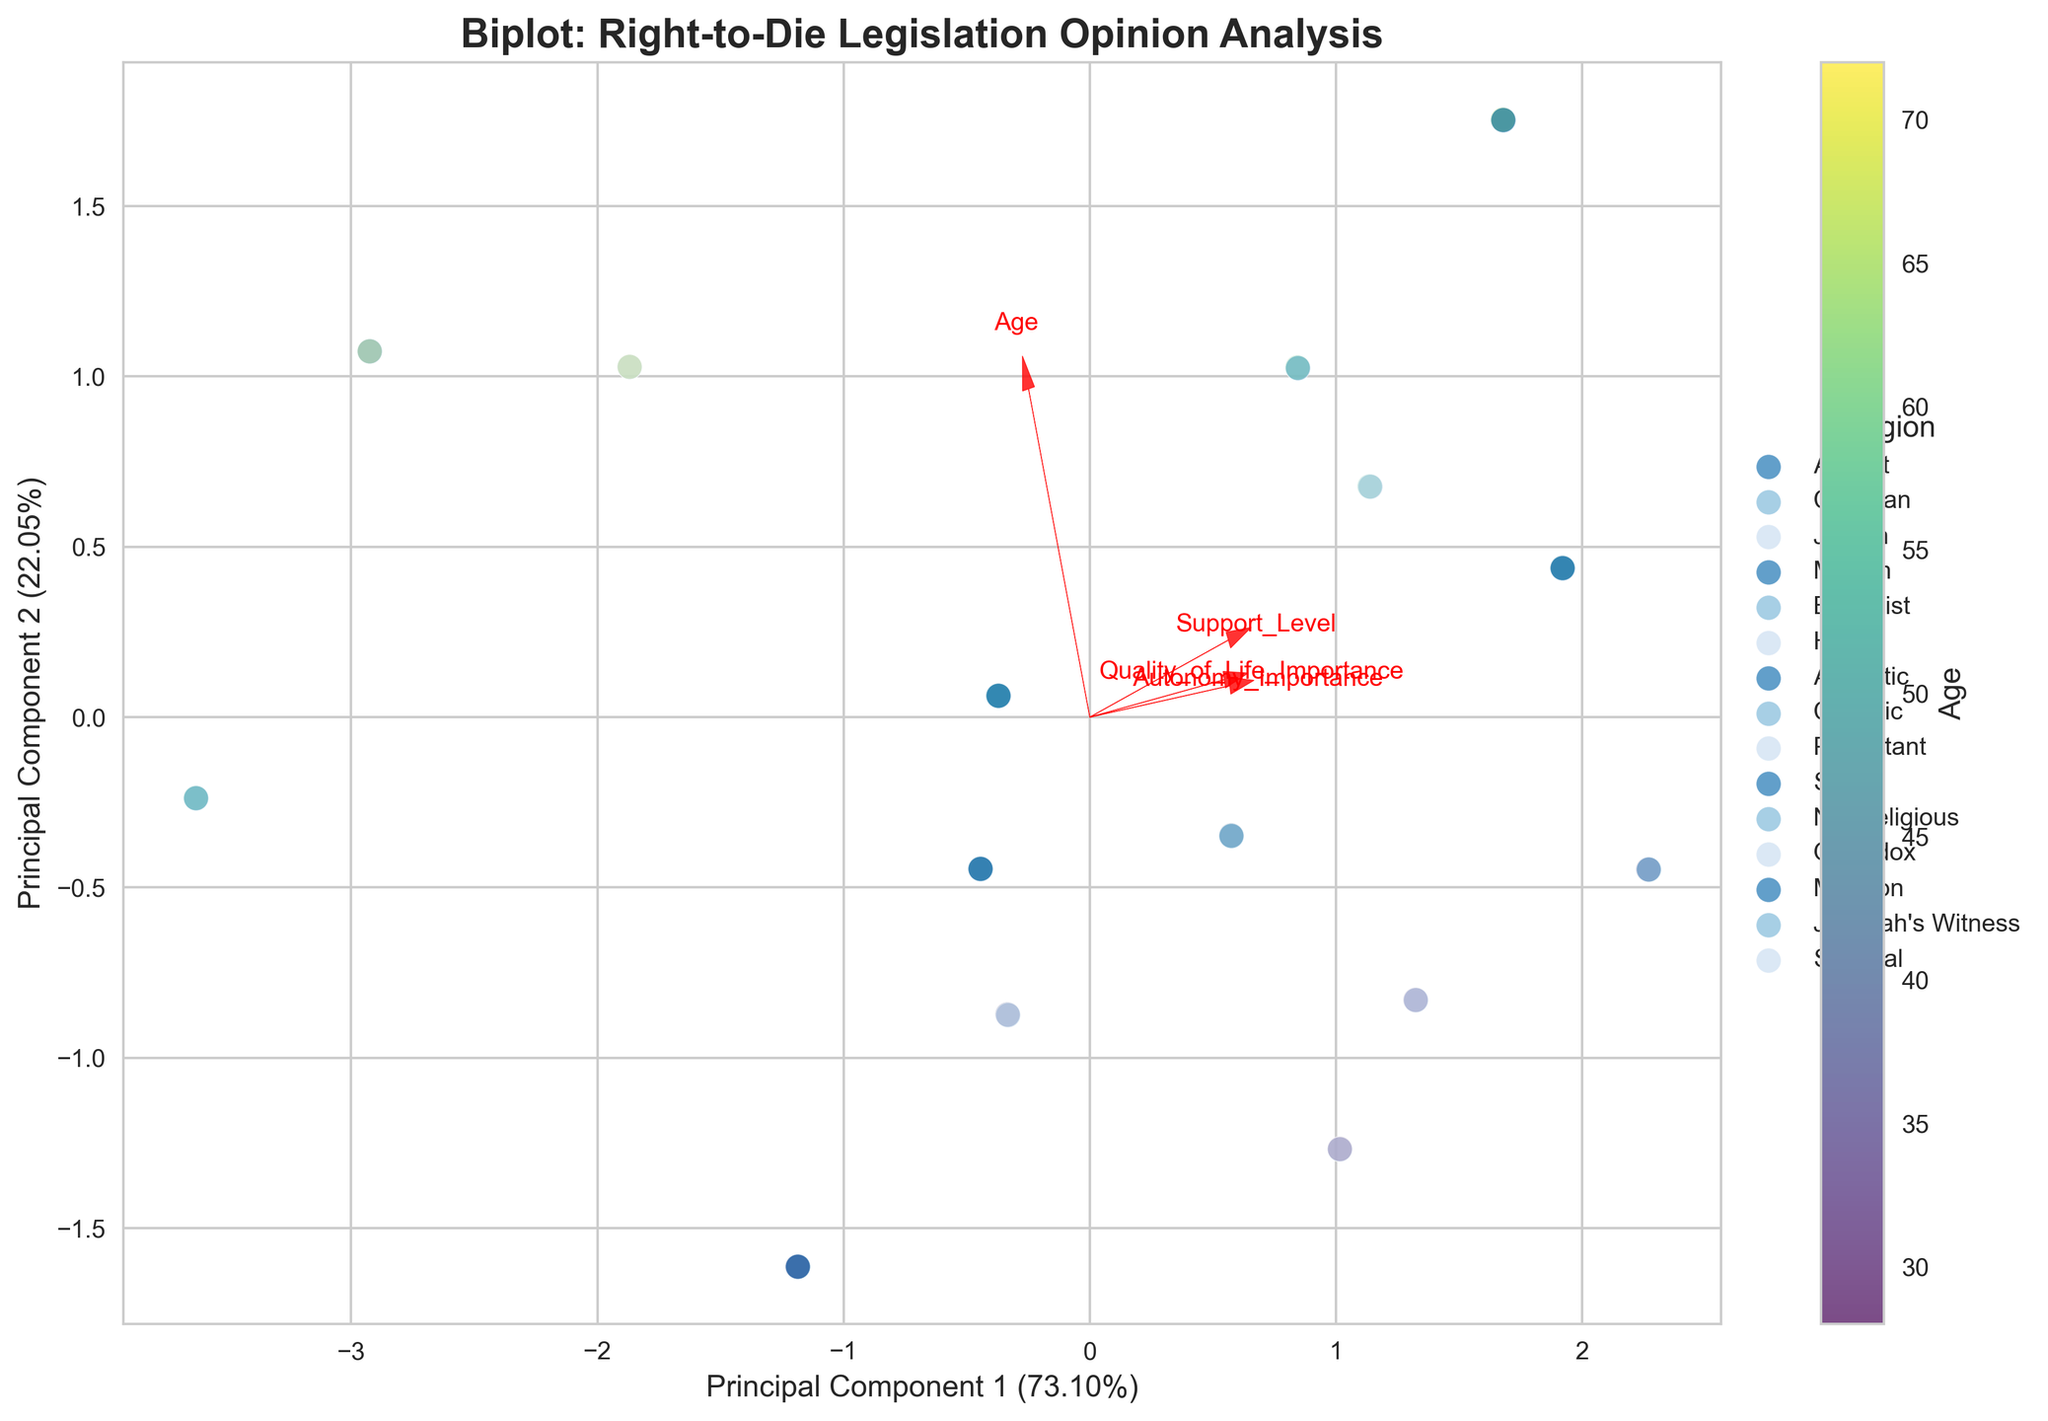What is the primary title of the biplot? The primary title of the biplot is clearly mentioned at the top of the figure.
Answer: Biplot: Right-to-Die Legislation Opinion Analysis What do the axes represent in this biplot? The x-axis and y-axis labels show what each axis represents.
Answer: Principal Component 1 and Principal Component 2 What feature has the highest loading on Principal Component 1? By observing the length and direction of the arrows, we can determine which feature has the highest loading.
Answer: Age Between 'Support_Level' and 'Quality_of_Life_Importance,' which feature aligns more closely with Principal Component 2? Comparing the direction and angle of the arrows relative to Principal Component 2 allows us to see which feature aligns more closely.
Answer: Quality_of_Life_Importance Which age group has the highest concentration in the scatter plot? By examining the color bar and the corresponding data points, we can identify the age group that appears most frequently.
Answer: 50-60 years Which religion's data points are clustered more closely together? Visual inspection of the clusters formed by data points labelled by religion shows which group is more tightly packed.
Answer: Agnostic How many religions are represented in the biplot? By counting the various legends representing each religion, we can determine the number.
Answer: 15 How does an individual's 'Autonomy_Importance' correlate with their 'Support_Level' based on this biplot? By looking at the direction and length of the 'Autonomy_Importance' and 'Support_Level' arrows, we can infer the correlation.
Answer: Positively correlated Which principal component explains more variance in the data? The explanation for each principal component's variance is given along with the axis labels.
Answer: Principal Component 1 Which demographic group appears to show the least support for right-to-die legislation? Observing the lower 'Support_Level' values and the data point labels, we can identify this demographic group.
Answer: Jehovah's Witnesses 